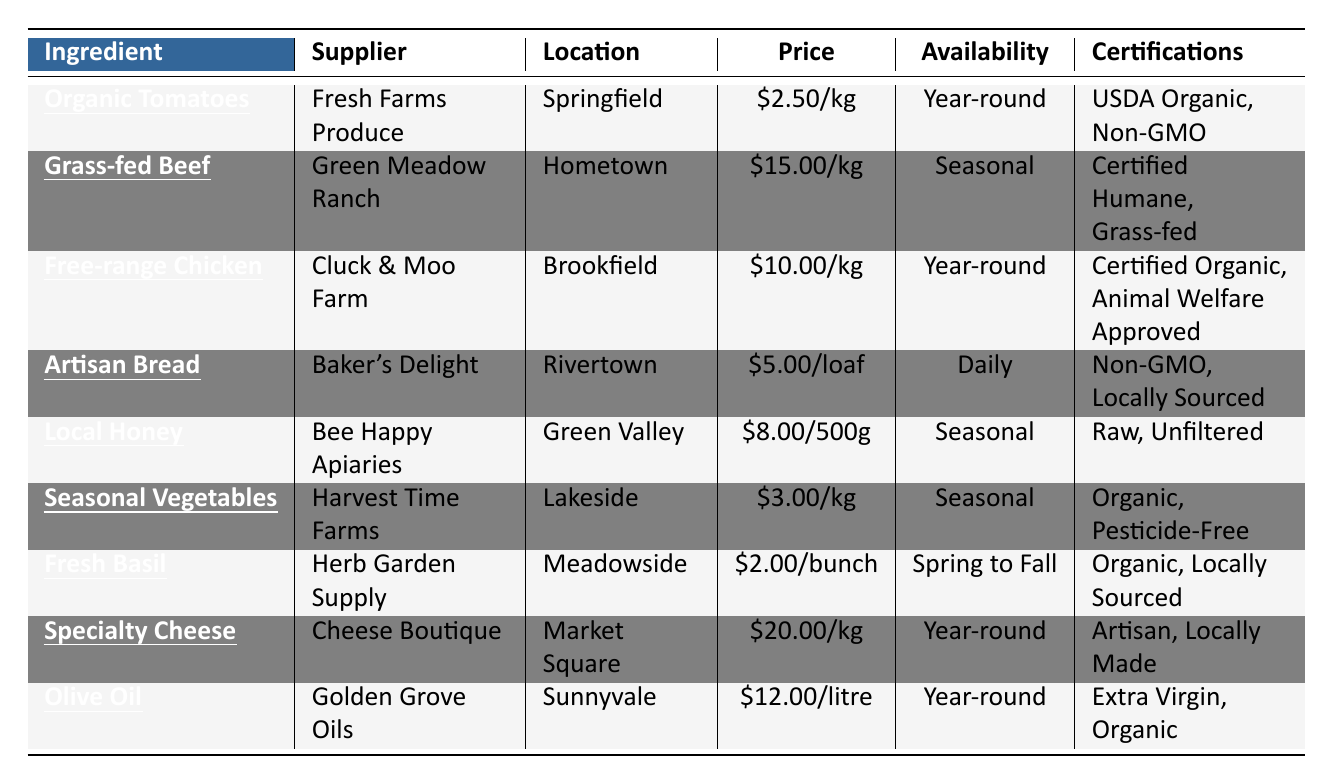What is the price per kilogram of Organic Tomatoes? The table shows that Organic Tomatoes are priced at \$2.50 per kilogram.
Answer: \$2.50/kg Which supplier provides Free-range Chicken? According to the table, Free-range Chicken is supplied by Cluck & Moo Farm.
Answer: Cluck & Moo Farm What is the availability period for Seasonal Vegetables? The table lists the availability of Seasonal Vegetables as "Seasonal."
Answer: Seasonal How much does Specialty Cheese cost per kilogram? Specialty Cheese is priced at \$20.00 per kilogram according to the table.
Answer: \$20.00/kg Are all ingredients certified organic? The table indicates that not all ingredients are certified organic; for example, Artisan Bread and Specialty Cheese are not listed as organic.
Answer: No How many ingredients have year-round availability? From the table, the ingredients with year-round availability are: Organic Tomatoes, Free-range Chicken, Specialty Cheese, and Olive Oil, totaling four ingredients.
Answer: 4 What is the price difference between Grass-fed Beef and Free-range Chicken? The price of Grass-fed Beef is \$15.00 per kg and the price of Free-range Chicken is \$10.00 per kg. The difference is \$15.00 - \$10.00 = \$5.00.
Answer: \$5.00 Which ingredient has the highest price and what is it? Upon reviewing the table, Specialty Cheese is the most expensive ingredient at \$20.00 per kilogram.
Answer: Specialty Cheese, \$20.00/kg Which supplier provides the majority of year-round ingredients? The suppliers for year-round ingredients are: Fresh Farms Produce, Cluck & Moo Farm, Cheese Boutique, and Golden Grove Oils, which totals four different suppliers. None provide the majority since they each provide one ingredient.
Answer: None provide the majority How many ingredients are sourced from suppliers with "locally sourced" certification? The table lists two ingredients with "Locally Sourced" certification: Artisan Bread and Fresh Basil.
Answer: 2 